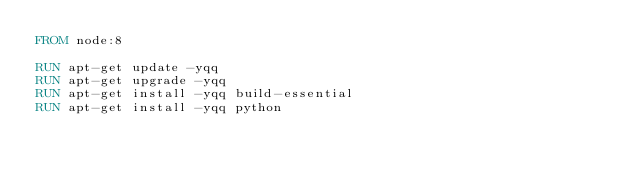Convert code to text. <code><loc_0><loc_0><loc_500><loc_500><_Dockerfile_>FROM node:8

RUN apt-get update -yqq
RUN apt-get upgrade -yqq
RUN apt-get install -yqq build-essential
RUN apt-get install -yqq python
</code> 